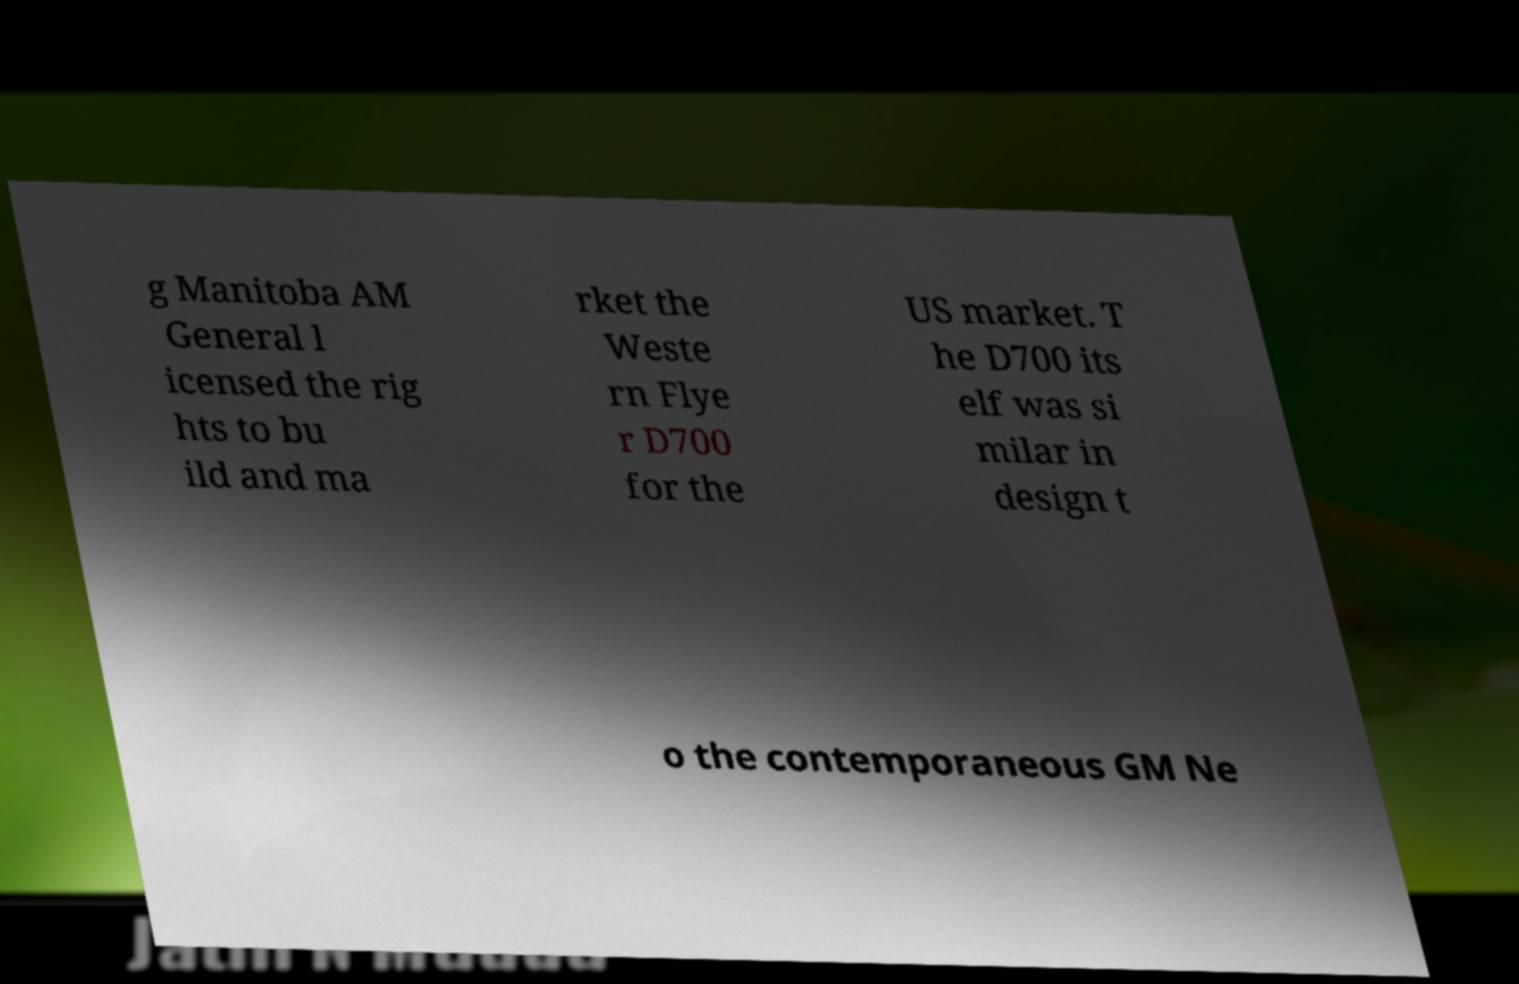Could you extract and type out the text from this image? g Manitoba AM General l icensed the rig hts to bu ild and ma rket the Weste rn Flye r D700 for the US market. T he D700 its elf was si milar in design t o the contemporaneous GM Ne 